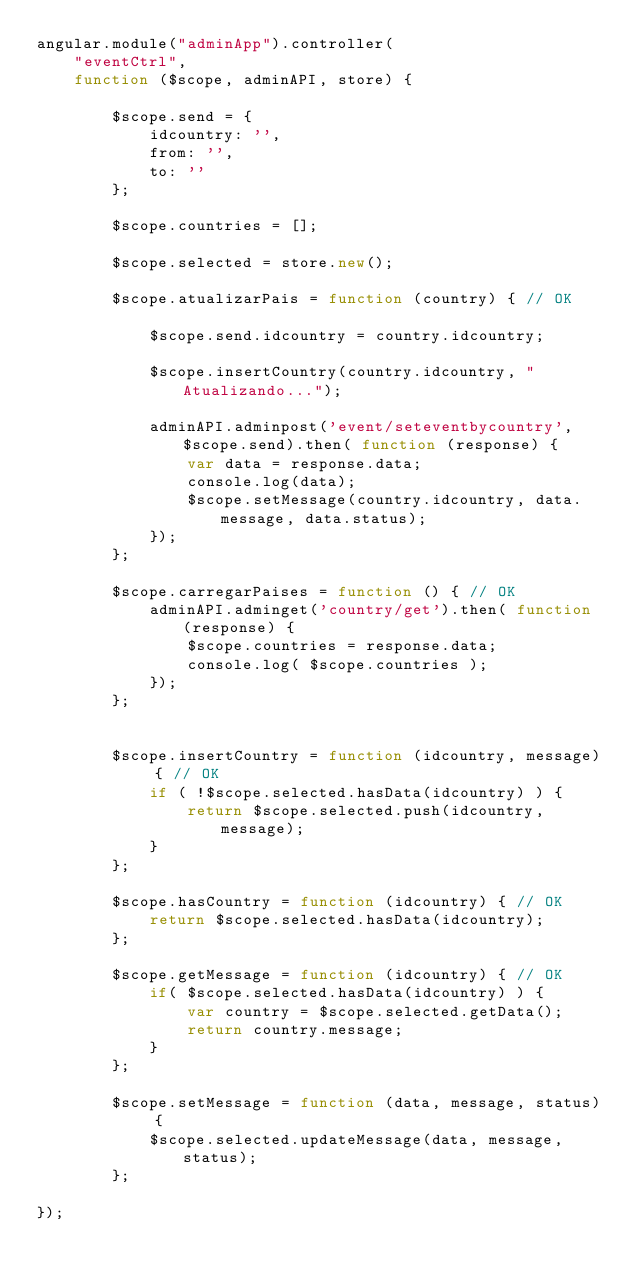<code> <loc_0><loc_0><loc_500><loc_500><_JavaScript_>angular.module("adminApp").controller(
	"eventCtrl", 
	function ($scope, adminAPI, store) {

		$scope.send = {
			idcountry: '',
			from: '',
			to: ''
		};

		$scope.countries = [];

		$scope.selected = store.new();

		$scope.atualizarPais = function (country) { // OK
			
			$scope.send.idcountry = country.idcountry;

			$scope.insertCountry(country.idcountry, "Atualizando...");
			
			adminAPI.adminpost('event/seteventbycountry', $scope.send).then( function (response) {
				var data = response.data;
				console.log(data);
				$scope.setMessage(country.idcountry, data.message, data.status);
			});
		};

		$scope.carregarPaises = function () { // OK
			adminAPI.adminget('country/get').then( function (response) {
				$scope.countries = response.data;
				console.log( $scope.countries );
			});
		};

		
		$scope.insertCountry = function (idcountry, message) { // OK
			if ( !$scope.selected.hasData(idcountry) ) {
				return $scope.selected.push(idcountry, message);
			}
		};

		$scope.hasCountry = function (idcountry) { // OK
			return $scope.selected.hasData(idcountry);
		};

		$scope.getMessage = function (idcountry) { // OK
			if( $scope.selected.hasData(idcountry) ) {
				var country = $scope.selected.getData();
				return country.message;
			}
		};

		$scope.setMessage = function (data, message, status) {
			$scope.selected.updateMessage(data, message, status);
		};

});</code> 